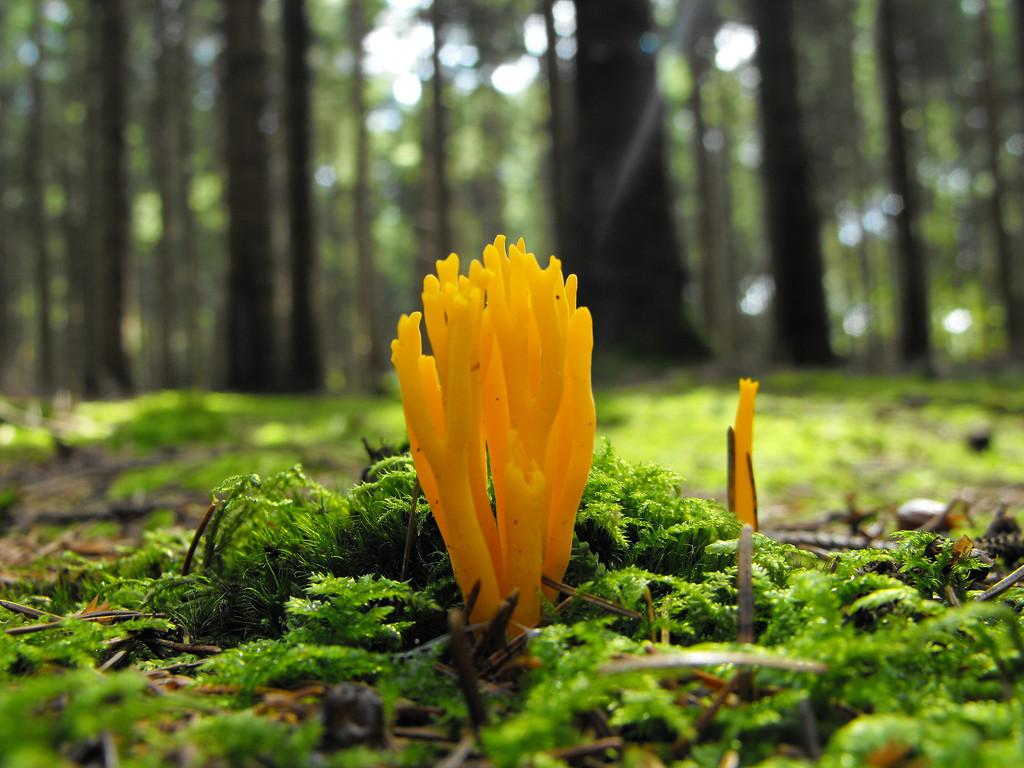What type of plant can be seen in the image? There is a flower in the image. What type of aquatic plant is present in the image? Algae is present in the image. What type of vegetation is visible on the ground in the image? Grass is visible in the image. What can be seen in the background of the image? There are trees in the background of the image. How does the sponge contribute to the pollution in the image? There is no sponge present in the image, and therefore no contribution to pollution can be observed. What type of hill is visible in the image? There is no hill present in the image. 